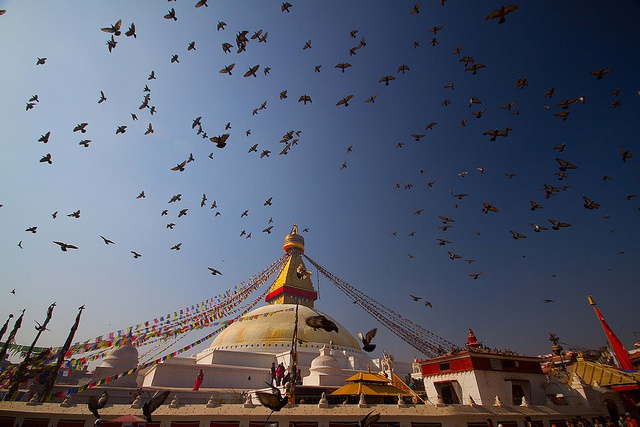Describe the objects in this image and their specific colors. I can see bird in darkgray, navy, black, and gray tones, bird in darkgray, black, maroon, and gray tones, people in darkgray, maroon, gray, black, and brown tones, bird in black, navy, maroon, and darkgray tones, and bird in black, navy, maroon, and darkgray tones in this image. 